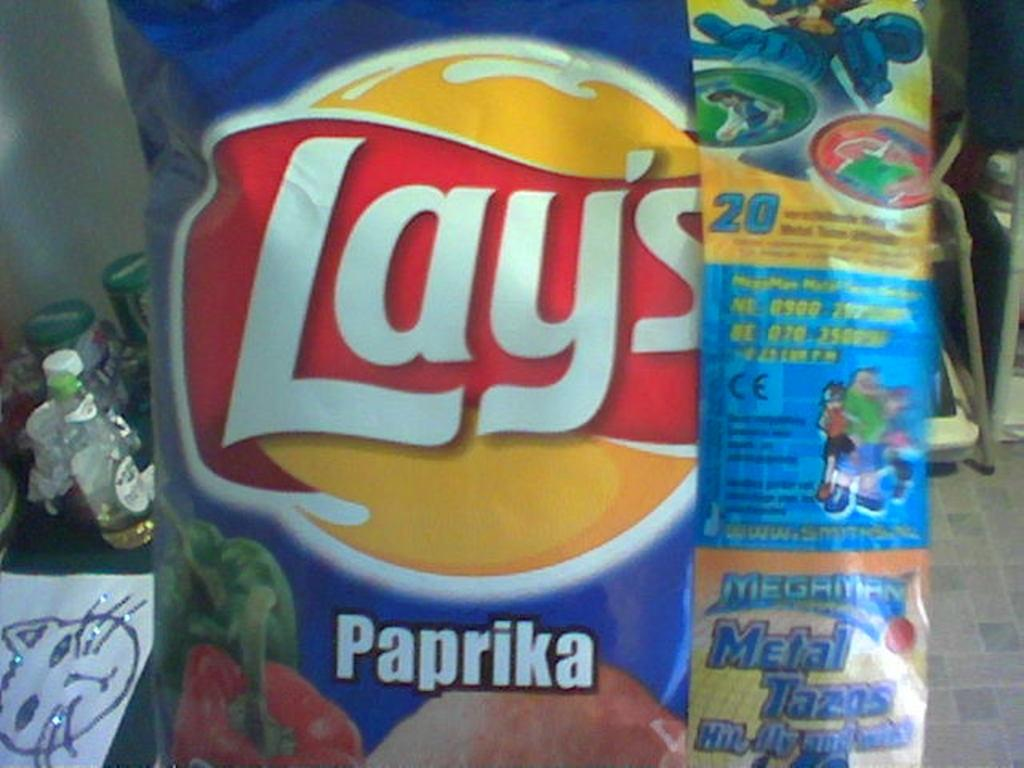What is on the cover that is visible in the image? There is a cover with writing on it. What can be seen in the background of the image? In the background, there are bottles, paper, and many other unspecified objects. Can you tell me how many basketballs are visible in the image? There are no basketballs present in the image. What type of plantation can be seen in the background of the image? There is no plantation present in the image; it only contains bottles, paper, and other unspecified objects in the background. 